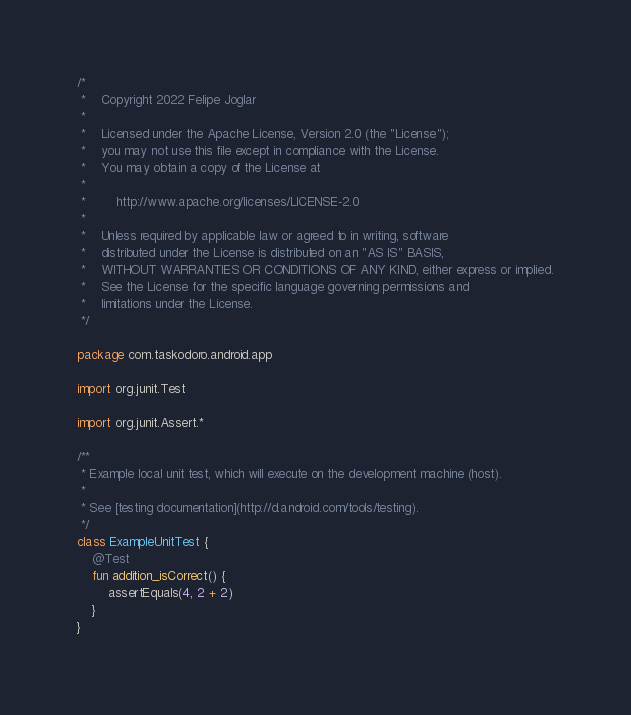<code> <loc_0><loc_0><loc_500><loc_500><_Kotlin_>/*
 *    Copyright 2022 Felipe Joglar
 *
 *    Licensed under the Apache License, Version 2.0 (the "License");
 *    you may not use this file except in compliance with the License.
 *    You may obtain a copy of the License at
 *
 *        http://www.apache.org/licenses/LICENSE-2.0
 *
 *    Unless required by applicable law or agreed to in writing, software
 *    distributed under the License is distributed on an "AS IS" BASIS,
 *    WITHOUT WARRANTIES OR CONDITIONS OF ANY KIND, either express or implied.
 *    See the License for the specific language governing permissions and
 *    limitations under the License.
 */

package com.taskodoro.android.app

import org.junit.Test

import org.junit.Assert.*

/**
 * Example local unit test, which will execute on the development machine (host).
 *
 * See [testing documentation](http://d.android.com/tools/testing).
 */
class ExampleUnitTest {
    @Test
    fun addition_isCorrect() {
        assertEquals(4, 2 + 2)
    }
}</code> 